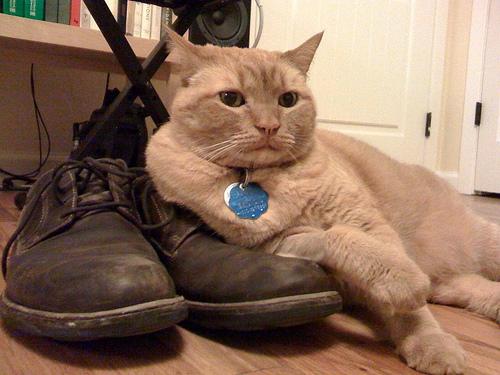What does the cat's tag say?
Keep it brief. Fluffy. What is the brand of shoe?
Give a very brief answer. Unknown. Is the cat looking at the camera?
Give a very brief answer. Yes. Are these shoes new?
Give a very brief answer. No. Where is the cat sitting?
Give a very brief answer. On shoes. Is the cat a solid color?
Write a very short answer. Yes. How many binders are on the shelf?
Write a very short answer. 8. Is the cat eating the shoe?
Keep it brief. No. Is the cat ready to pounce?
Short answer required. No. What is the animal sitting on?
Write a very short answer. Shoes. What is the cat wearing?
Keep it brief. Collar. 